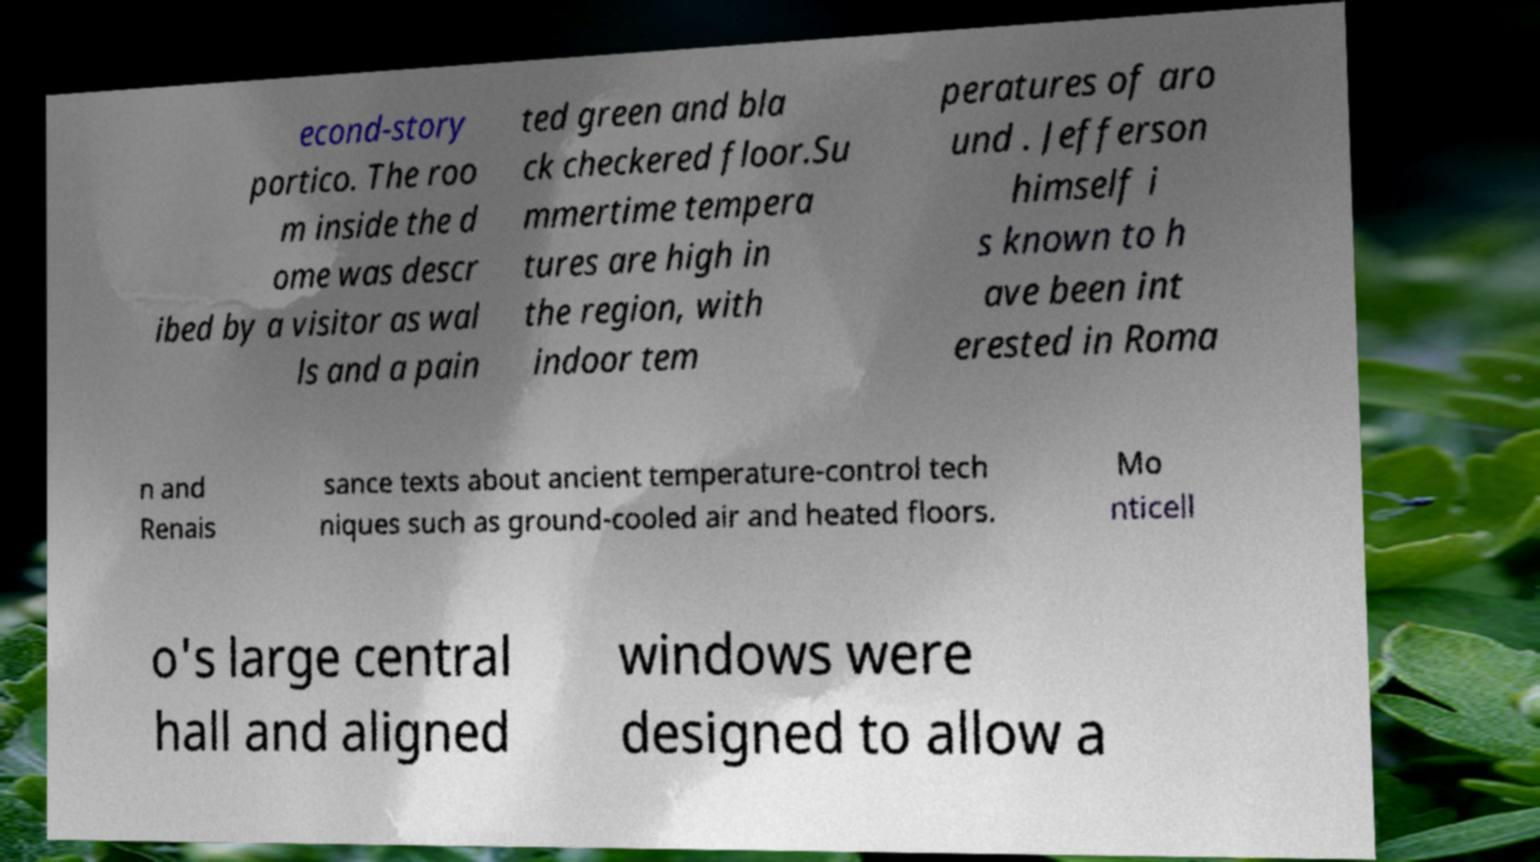Can you read and provide the text displayed in the image?This photo seems to have some interesting text. Can you extract and type it out for me? econd-story portico. The roo m inside the d ome was descr ibed by a visitor as wal ls and a pain ted green and bla ck checkered floor.Su mmertime tempera tures are high in the region, with indoor tem peratures of aro und . Jefferson himself i s known to h ave been int erested in Roma n and Renais sance texts about ancient temperature-control tech niques such as ground-cooled air and heated floors. Mo nticell o's large central hall and aligned windows were designed to allow a 